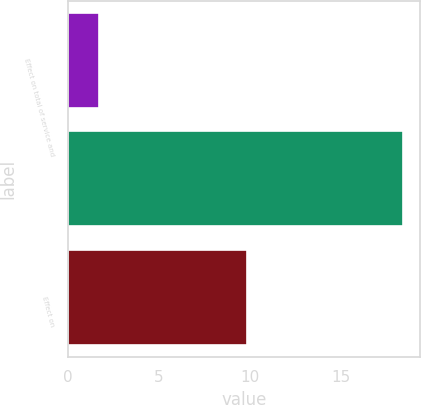Convert chart to OTSL. <chart><loc_0><loc_0><loc_500><loc_500><bar_chart><fcel>Effect on total of service and<fcel>Unnamed: 1<fcel>Effect on<nl><fcel>1.7<fcel>18.4<fcel>9.8<nl></chart> 